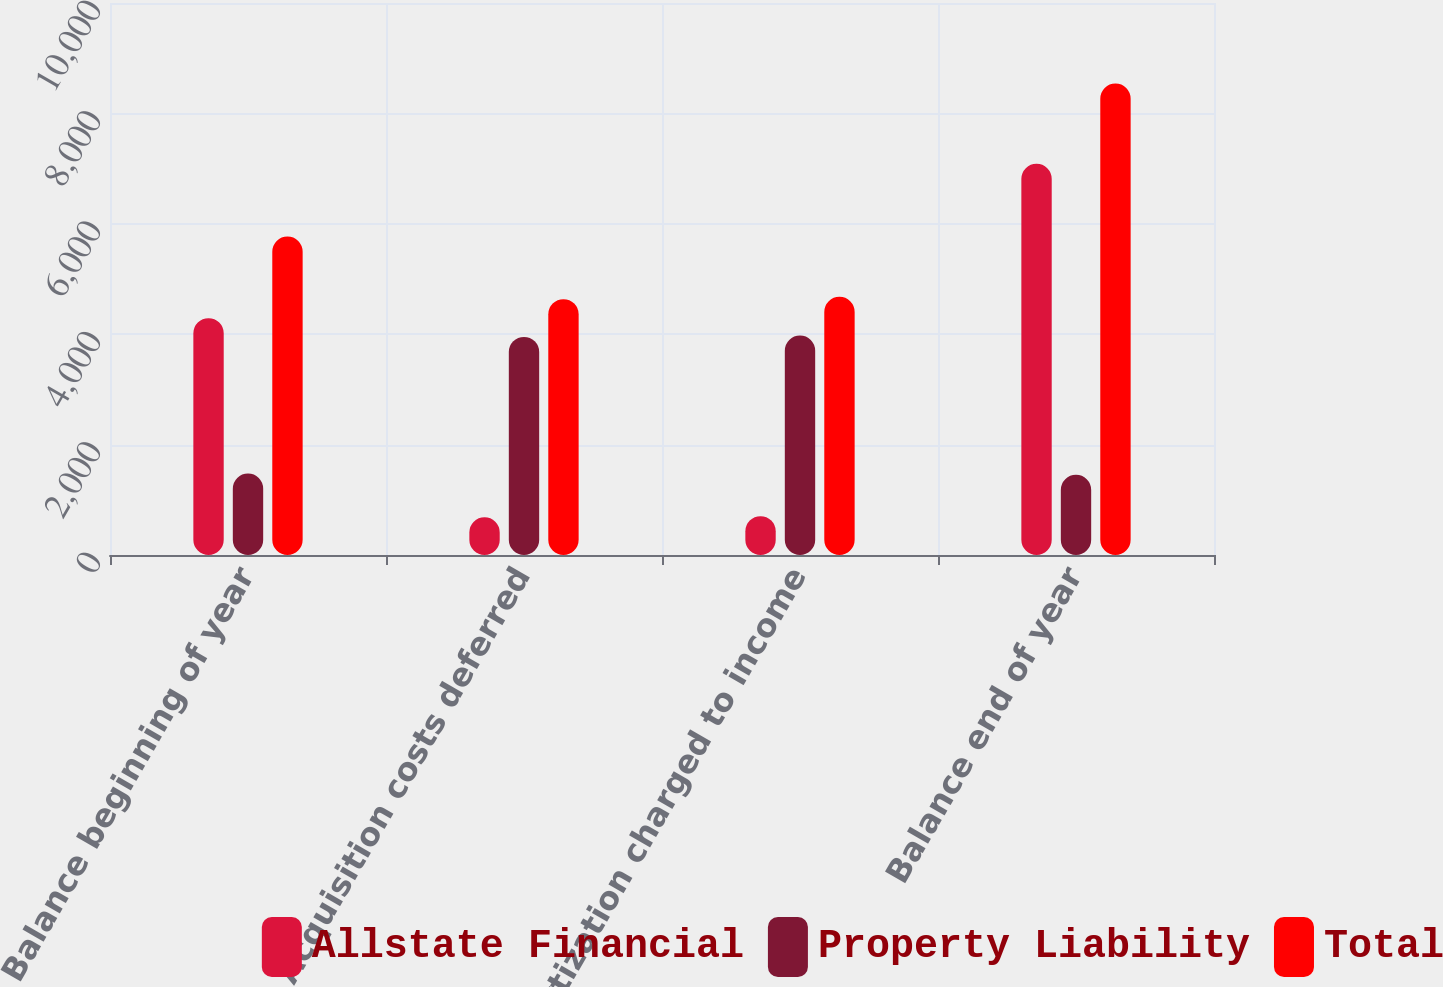Convert chart. <chart><loc_0><loc_0><loc_500><loc_500><stacked_bar_chart><ecel><fcel>Balance beginning of year<fcel>Acquisition costs deferred<fcel>Amortization charged to income<fcel>Balance end of year<nl><fcel>Allstate Financial<fcel>4291<fcel>684<fcel>704<fcel>7089<nl><fcel>Property Liability<fcel>1477<fcel>3951<fcel>3975<fcel>1453<nl><fcel>Total<fcel>5768<fcel>4635<fcel>4679<fcel>8542<nl></chart> 